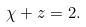<formula> <loc_0><loc_0><loc_500><loc_500>\chi + z = 2 .</formula> 